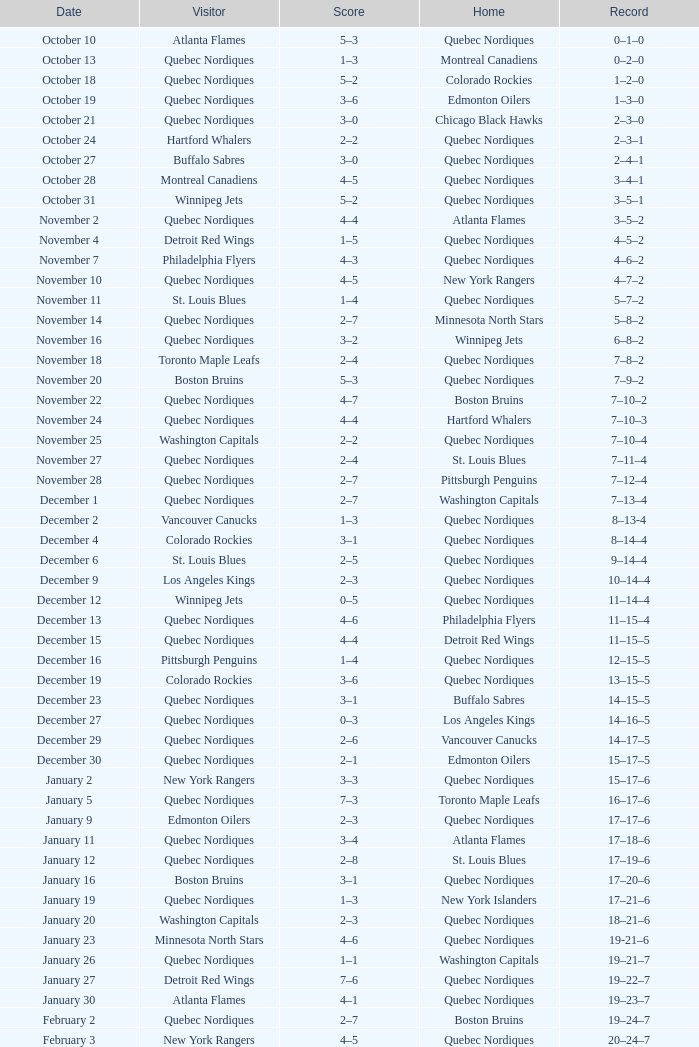Which Home has a Record of 11–14–4? Quebec Nordiques. 